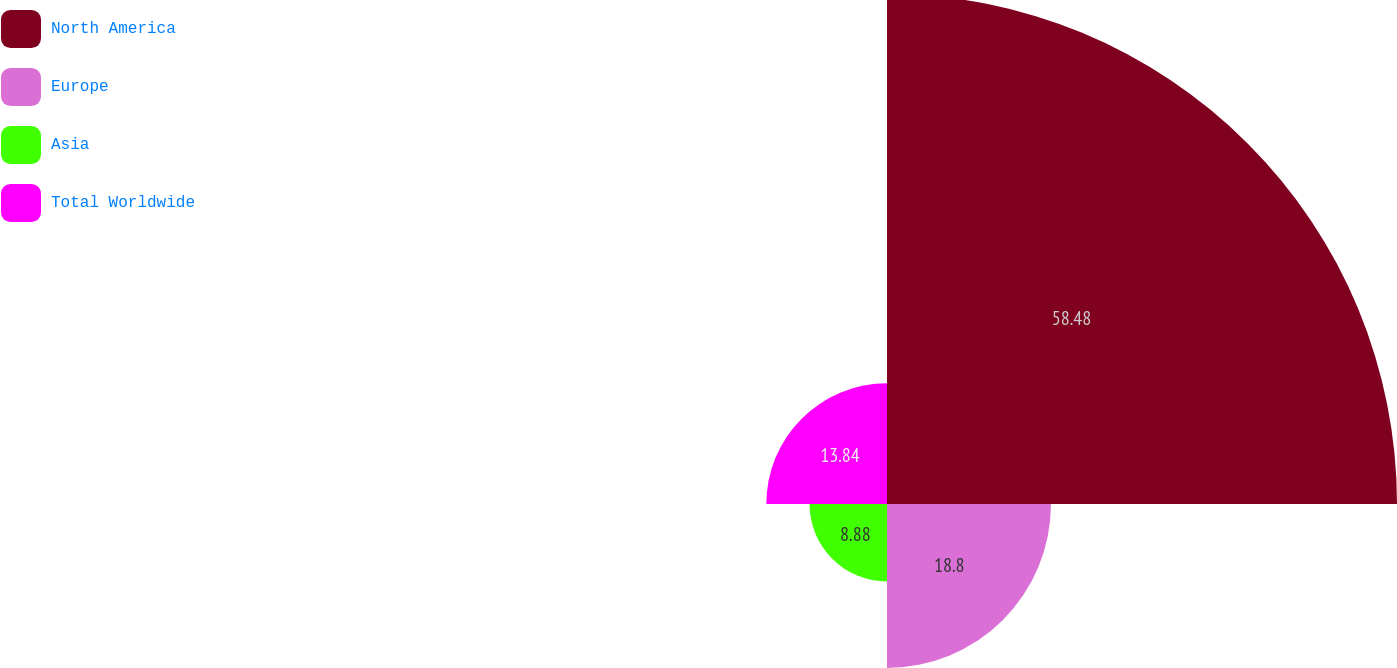<chart> <loc_0><loc_0><loc_500><loc_500><pie_chart><fcel>North America<fcel>Europe<fcel>Asia<fcel>Total Worldwide<nl><fcel>58.48%<fcel>18.8%<fcel>8.88%<fcel>13.84%<nl></chart> 